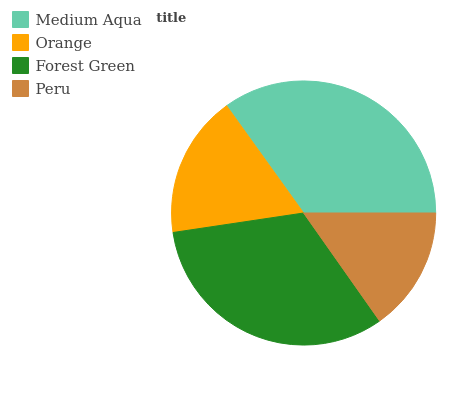Is Peru the minimum?
Answer yes or no. Yes. Is Medium Aqua the maximum?
Answer yes or no. Yes. Is Orange the minimum?
Answer yes or no. No. Is Orange the maximum?
Answer yes or no. No. Is Medium Aqua greater than Orange?
Answer yes or no. Yes. Is Orange less than Medium Aqua?
Answer yes or no. Yes. Is Orange greater than Medium Aqua?
Answer yes or no. No. Is Medium Aqua less than Orange?
Answer yes or no. No. Is Forest Green the high median?
Answer yes or no. Yes. Is Orange the low median?
Answer yes or no. Yes. Is Orange the high median?
Answer yes or no. No. Is Peru the low median?
Answer yes or no. No. 